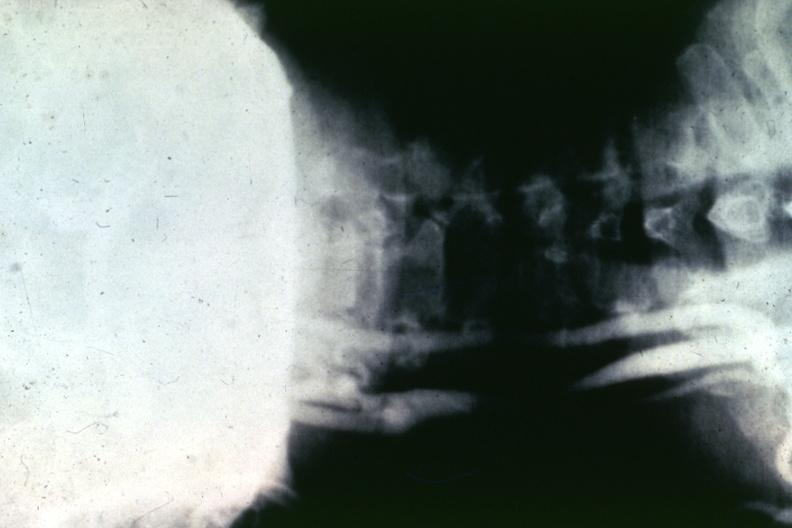s cardiovascular present?
Answer the question using a single word or phrase. Yes 